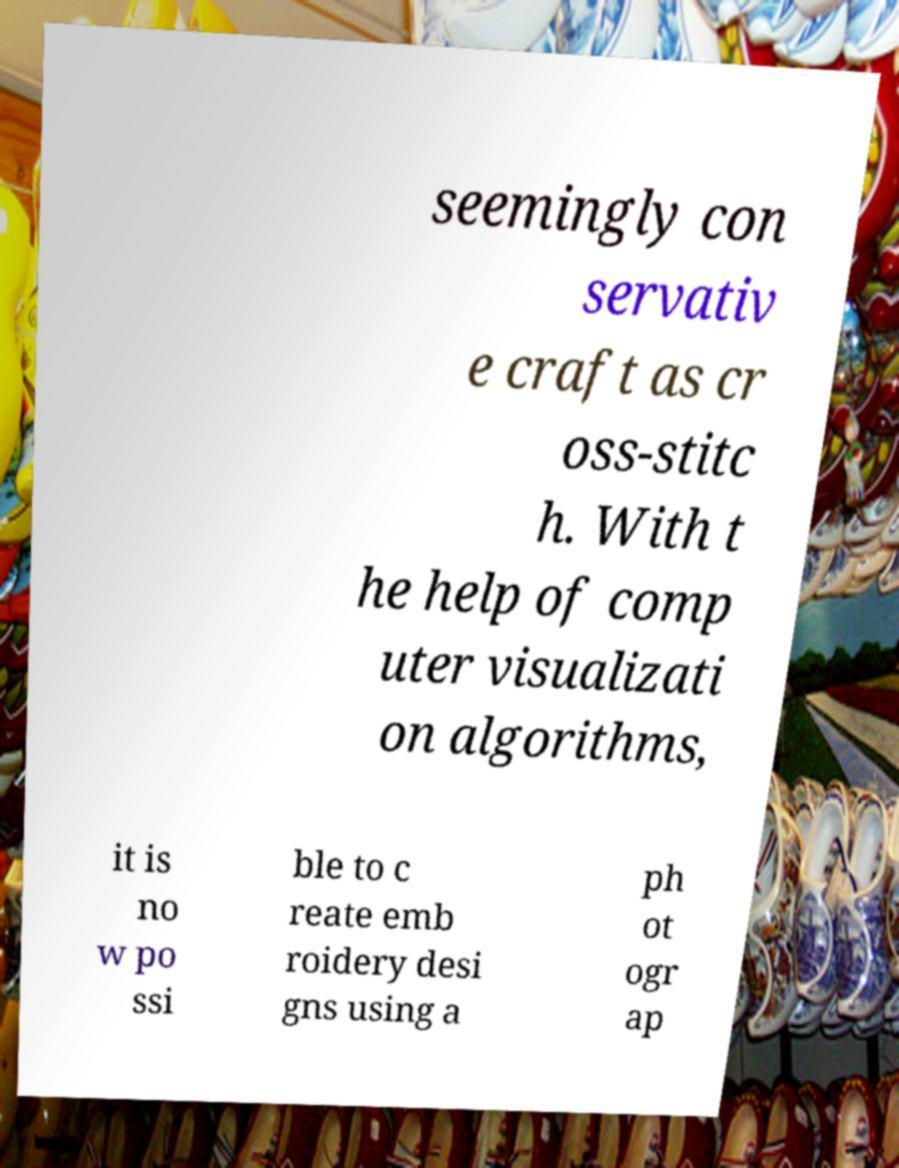Please read and relay the text visible in this image. What does it say? seemingly con servativ e craft as cr oss-stitc h. With t he help of comp uter visualizati on algorithms, it is no w po ssi ble to c reate emb roidery desi gns using a ph ot ogr ap 